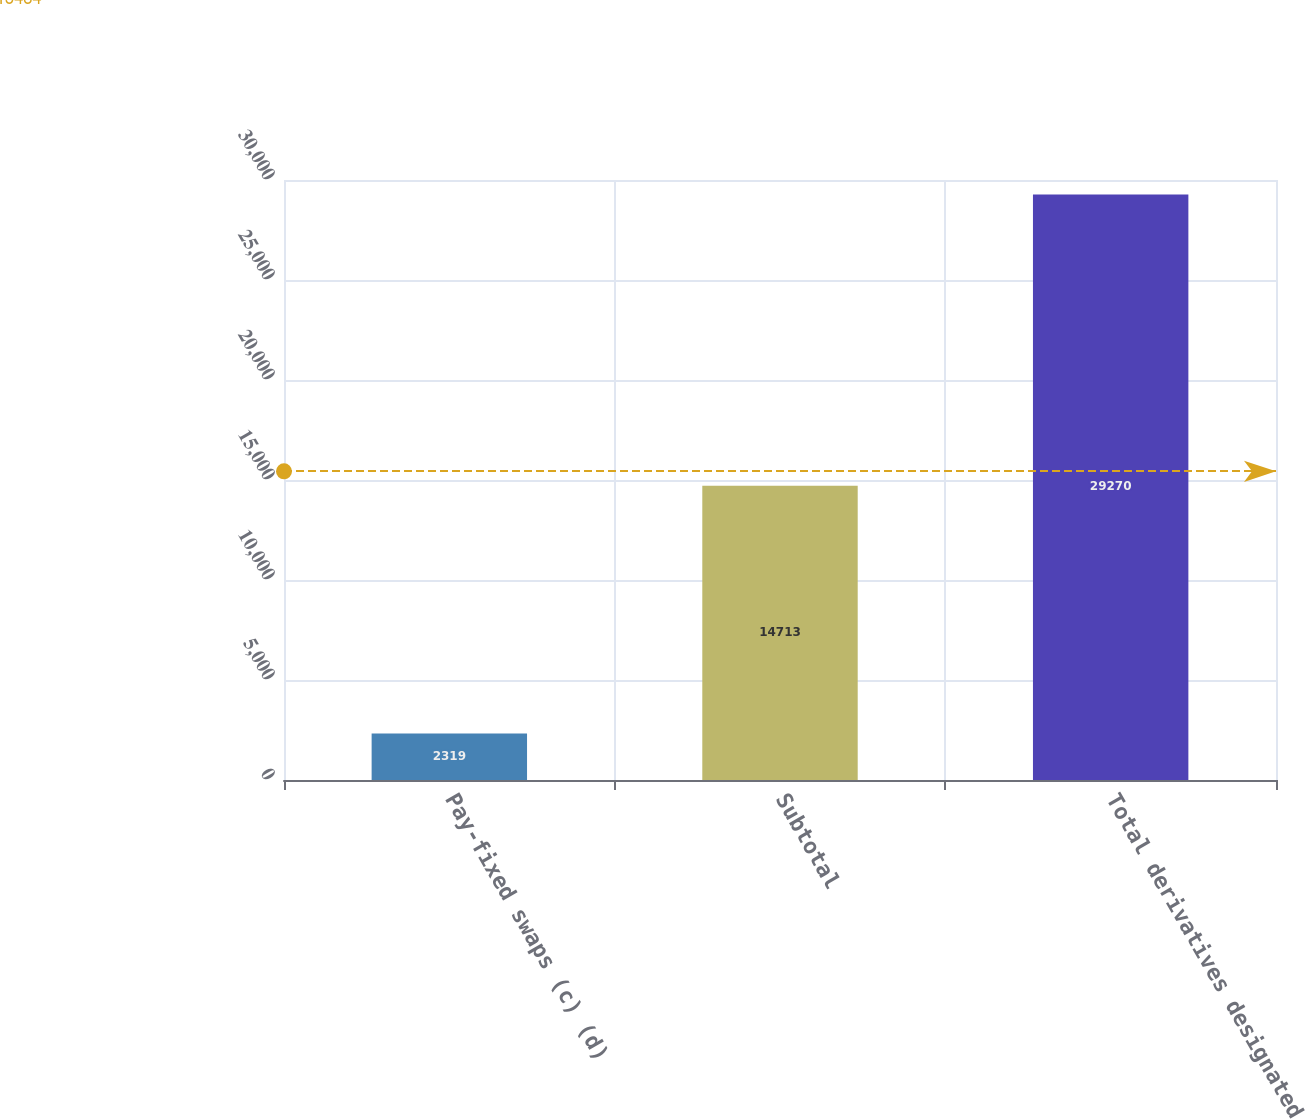Convert chart. <chart><loc_0><loc_0><loc_500><loc_500><bar_chart><fcel>Pay-fixed swaps (c) (d)<fcel>Subtotal<fcel>Total derivatives designated<nl><fcel>2319<fcel>14713<fcel>29270<nl></chart> 